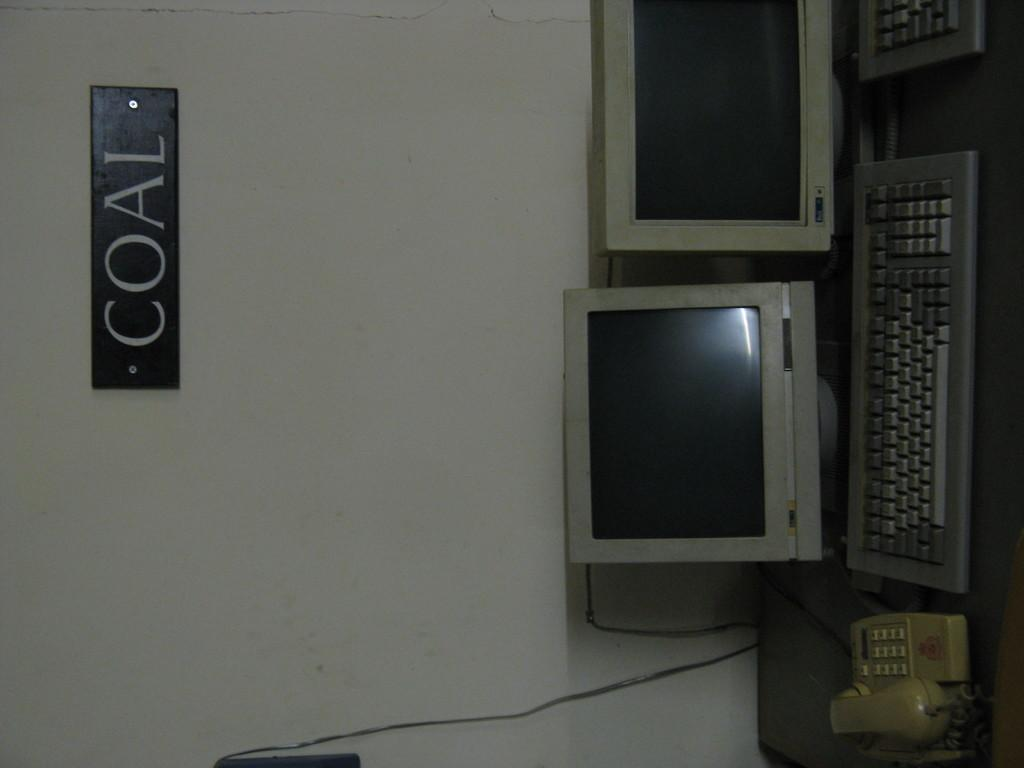<image>
Give a short and clear explanation of the subsequent image. couple of crt monitors and keyboards on table with a sign on the wall with word coal on it 